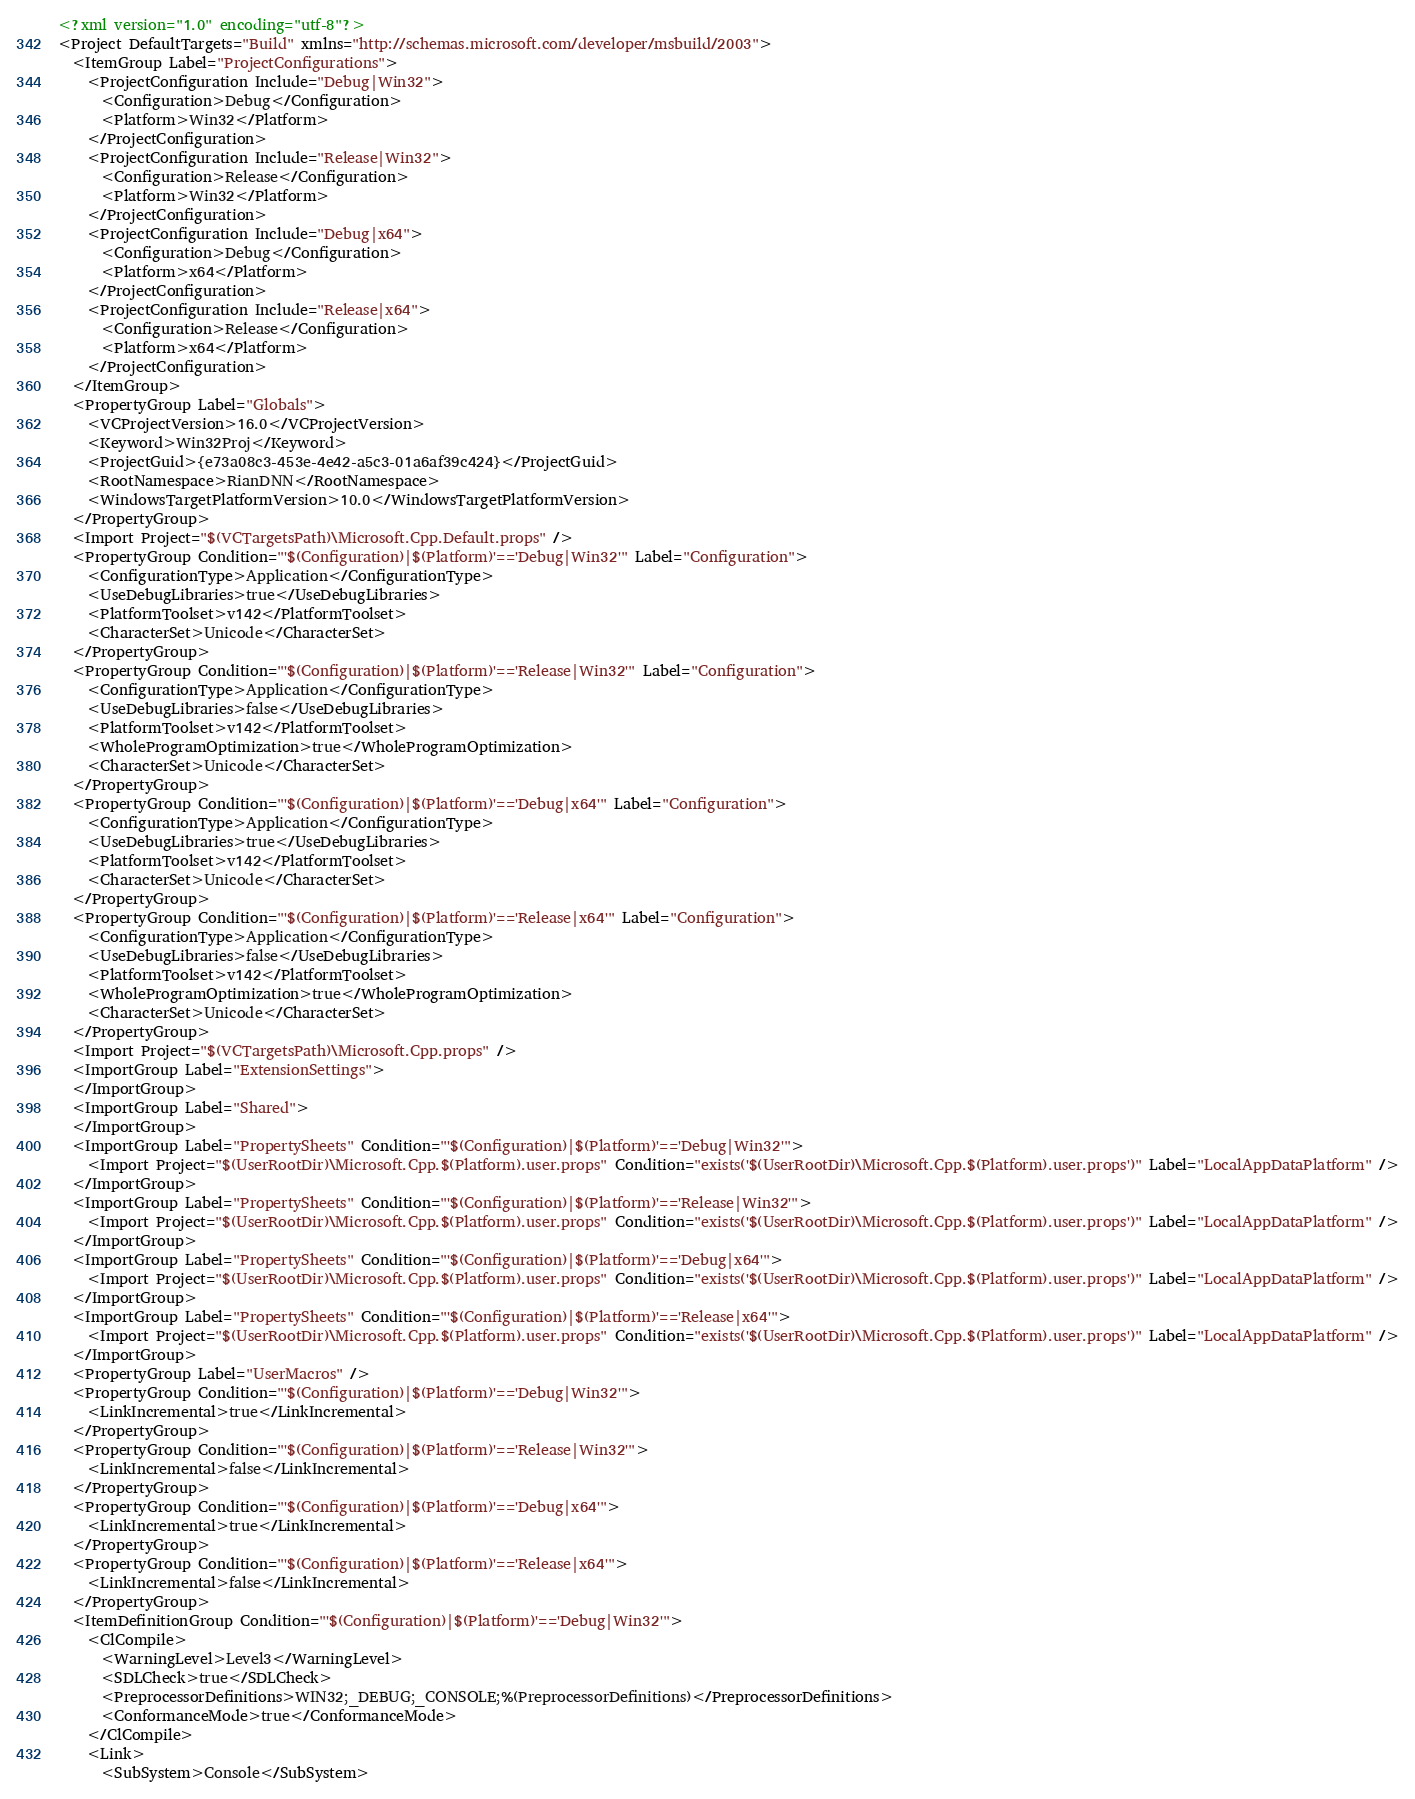<code> <loc_0><loc_0><loc_500><loc_500><_XML_><?xml version="1.0" encoding="utf-8"?>
<Project DefaultTargets="Build" xmlns="http://schemas.microsoft.com/developer/msbuild/2003">
  <ItemGroup Label="ProjectConfigurations">
    <ProjectConfiguration Include="Debug|Win32">
      <Configuration>Debug</Configuration>
      <Platform>Win32</Platform>
    </ProjectConfiguration>
    <ProjectConfiguration Include="Release|Win32">
      <Configuration>Release</Configuration>
      <Platform>Win32</Platform>
    </ProjectConfiguration>
    <ProjectConfiguration Include="Debug|x64">
      <Configuration>Debug</Configuration>
      <Platform>x64</Platform>
    </ProjectConfiguration>
    <ProjectConfiguration Include="Release|x64">
      <Configuration>Release</Configuration>
      <Platform>x64</Platform>
    </ProjectConfiguration>
  </ItemGroup>
  <PropertyGroup Label="Globals">
    <VCProjectVersion>16.0</VCProjectVersion>
    <Keyword>Win32Proj</Keyword>
    <ProjectGuid>{e73a08c3-453e-4e42-a5c3-01a6af39c424}</ProjectGuid>
    <RootNamespace>RianDNN</RootNamespace>
    <WindowsTargetPlatformVersion>10.0</WindowsTargetPlatformVersion>
  </PropertyGroup>
  <Import Project="$(VCTargetsPath)\Microsoft.Cpp.Default.props" />
  <PropertyGroup Condition="'$(Configuration)|$(Platform)'=='Debug|Win32'" Label="Configuration">
    <ConfigurationType>Application</ConfigurationType>
    <UseDebugLibraries>true</UseDebugLibraries>
    <PlatformToolset>v142</PlatformToolset>
    <CharacterSet>Unicode</CharacterSet>
  </PropertyGroup>
  <PropertyGroup Condition="'$(Configuration)|$(Platform)'=='Release|Win32'" Label="Configuration">
    <ConfigurationType>Application</ConfigurationType>
    <UseDebugLibraries>false</UseDebugLibraries>
    <PlatformToolset>v142</PlatformToolset>
    <WholeProgramOptimization>true</WholeProgramOptimization>
    <CharacterSet>Unicode</CharacterSet>
  </PropertyGroup>
  <PropertyGroup Condition="'$(Configuration)|$(Platform)'=='Debug|x64'" Label="Configuration">
    <ConfigurationType>Application</ConfigurationType>
    <UseDebugLibraries>true</UseDebugLibraries>
    <PlatformToolset>v142</PlatformToolset>
    <CharacterSet>Unicode</CharacterSet>
  </PropertyGroup>
  <PropertyGroup Condition="'$(Configuration)|$(Platform)'=='Release|x64'" Label="Configuration">
    <ConfigurationType>Application</ConfigurationType>
    <UseDebugLibraries>false</UseDebugLibraries>
    <PlatformToolset>v142</PlatformToolset>
    <WholeProgramOptimization>true</WholeProgramOptimization>
    <CharacterSet>Unicode</CharacterSet>
  </PropertyGroup>
  <Import Project="$(VCTargetsPath)\Microsoft.Cpp.props" />
  <ImportGroup Label="ExtensionSettings">
  </ImportGroup>
  <ImportGroup Label="Shared">
  </ImportGroup>
  <ImportGroup Label="PropertySheets" Condition="'$(Configuration)|$(Platform)'=='Debug|Win32'">
    <Import Project="$(UserRootDir)\Microsoft.Cpp.$(Platform).user.props" Condition="exists('$(UserRootDir)\Microsoft.Cpp.$(Platform).user.props')" Label="LocalAppDataPlatform" />
  </ImportGroup>
  <ImportGroup Label="PropertySheets" Condition="'$(Configuration)|$(Platform)'=='Release|Win32'">
    <Import Project="$(UserRootDir)\Microsoft.Cpp.$(Platform).user.props" Condition="exists('$(UserRootDir)\Microsoft.Cpp.$(Platform).user.props')" Label="LocalAppDataPlatform" />
  </ImportGroup>
  <ImportGroup Label="PropertySheets" Condition="'$(Configuration)|$(Platform)'=='Debug|x64'">
    <Import Project="$(UserRootDir)\Microsoft.Cpp.$(Platform).user.props" Condition="exists('$(UserRootDir)\Microsoft.Cpp.$(Platform).user.props')" Label="LocalAppDataPlatform" />
  </ImportGroup>
  <ImportGroup Label="PropertySheets" Condition="'$(Configuration)|$(Platform)'=='Release|x64'">
    <Import Project="$(UserRootDir)\Microsoft.Cpp.$(Platform).user.props" Condition="exists('$(UserRootDir)\Microsoft.Cpp.$(Platform).user.props')" Label="LocalAppDataPlatform" />
  </ImportGroup>
  <PropertyGroup Label="UserMacros" />
  <PropertyGroup Condition="'$(Configuration)|$(Platform)'=='Debug|Win32'">
    <LinkIncremental>true</LinkIncremental>
  </PropertyGroup>
  <PropertyGroup Condition="'$(Configuration)|$(Platform)'=='Release|Win32'">
    <LinkIncremental>false</LinkIncremental>
  </PropertyGroup>
  <PropertyGroup Condition="'$(Configuration)|$(Platform)'=='Debug|x64'">
    <LinkIncremental>true</LinkIncremental>
  </PropertyGroup>
  <PropertyGroup Condition="'$(Configuration)|$(Platform)'=='Release|x64'">
    <LinkIncremental>false</LinkIncremental>
  </PropertyGroup>
  <ItemDefinitionGroup Condition="'$(Configuration)|$(Platform)'=='Debug|Win32'">
    <ClCompile>
      <WarningLevel>Level3</WarningLevel>
      <SDLCheck>true</SDLCheck>
      <PreprocessorDefinitions>WIN32;_DEBUG;_CONSOLE;%(PreprocessorDefinitions)</PreprocessorDefinitions>
      <ConformanceMode>true</ConformanceMode>
    </ClCompile>
    <Link>
      <SubSystem>Console</SubSystem></code> 